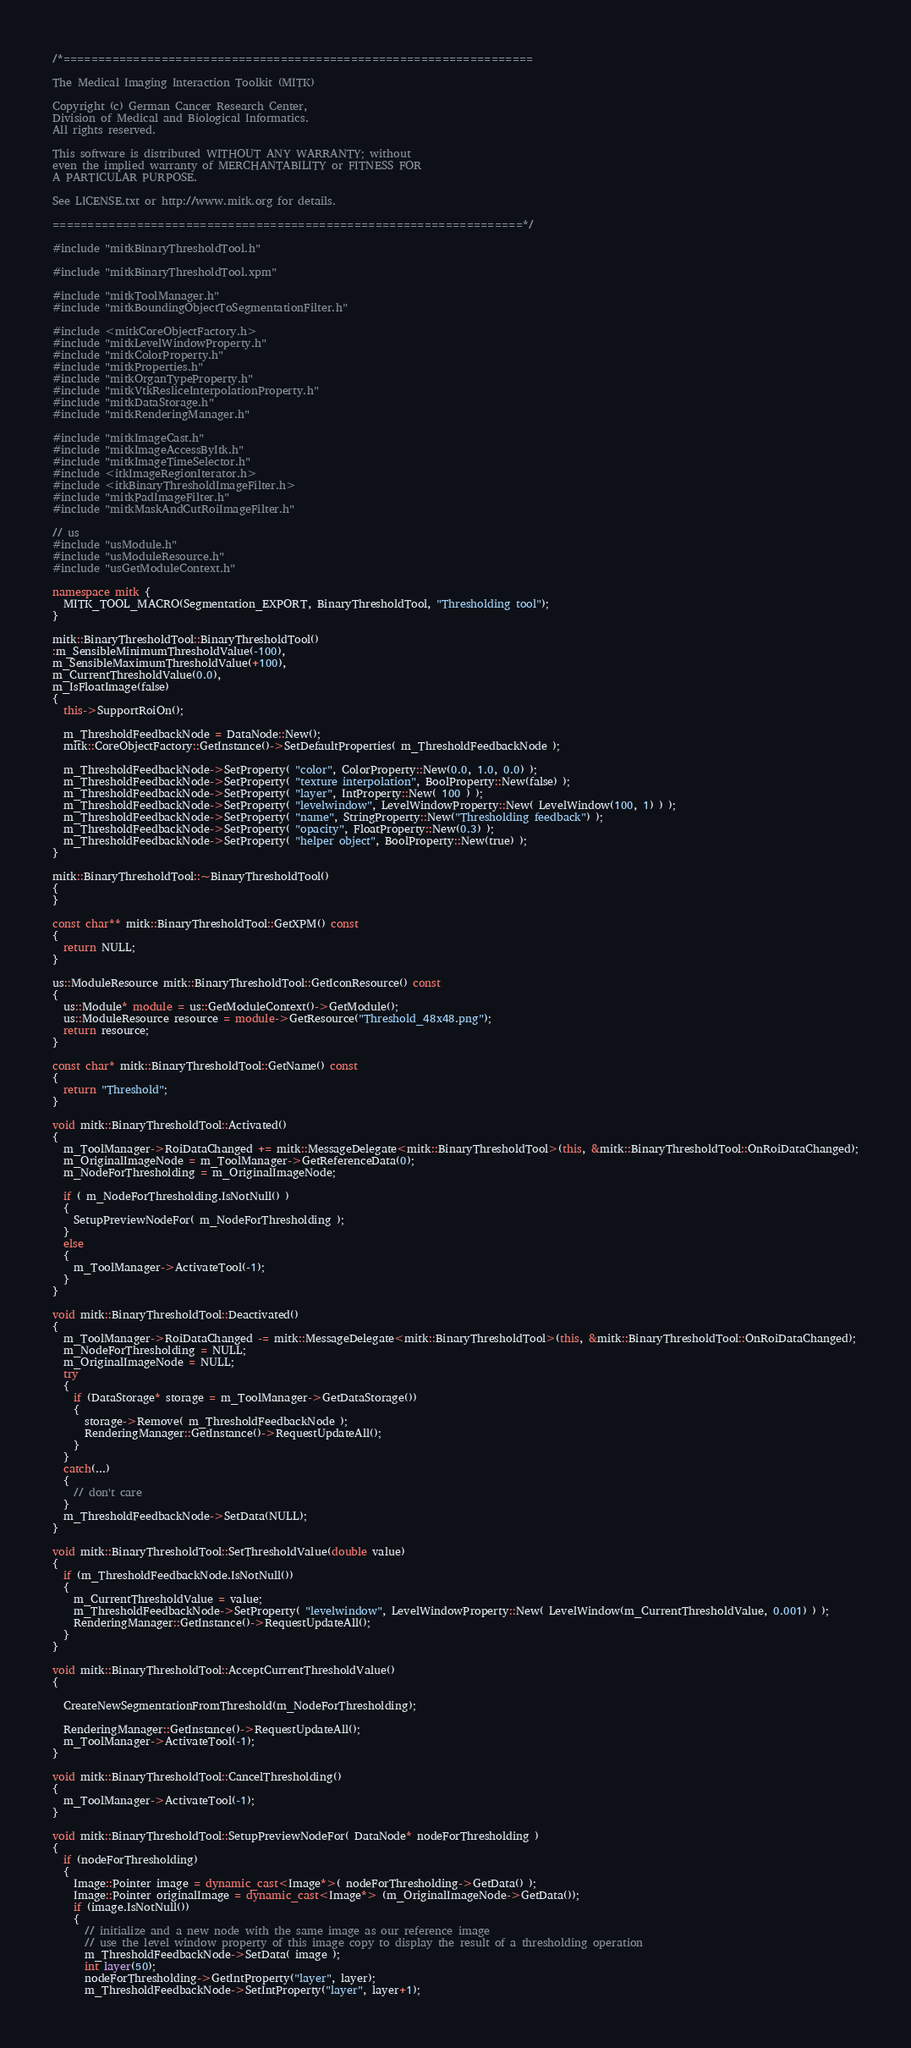Convert code to text. <code><loc_0><loc_0><loc_500><loc_500><_C++_>/*===================================================================

The Medical Imaging Interaction Toolkit (MITK)

Copyright (c) German Cancer Research Center,
Division of Medical and Biological Informatics.
All rights reserved.

This software is distributed WITHOUT ANY WARRANTY; without
even the implied warranty of MERCHANTABILITY or FITNESS FOR
A PARTICULAR PURPOSE.

See LICENSE.txt or http://www.mitk.org for details.

===================================================================*/

#include "mitkBinaryThresholdTool.h"

#include "mitkBinaryThresholdTool.xpm"

#include "mitkToolManager.h"
#include "mitkBoundingObjectToSegmentationFilter.h"

#include <mitkCoreObjectFactory.h>
#include "mitkLevelWindowProperty.h"
#include "mitkColorProperty.h"
#include "mitkProperties.h"
#include "mitkOrganTypeProperty.h"
#include "mitkVtkResliceInterpolationProperty.h"
#include "mitkDataStorage.h"
#include "mitkRenderingManager.h"

#include "mitkImageCast.h"
#include "mitkImageAccessByItk.h"
#include "mitkImageTimeSelector.h"
#include <itkImageRegionIterator.h>
#include <itkBinaryThresholdImageFilter.h>
#include "mitkPadImageFilter.h"
#include "mitkMaskAndCutRoiImageFilter.h"

// us
#include "usModule.h"
#include "usModuleResource.h"
#include "usGetModuleContext.h"

namespace mitk {
  MITK_TOOL_MACRO(Segmentation_EXPORT, BinaryThresholdTool, "Thresholding tool");
}

mitk::BinaryThresholdTool::BinaryThresholdTool()
:m_SensibleMinimumThresholdValue(-100),
m_SensibleMaximumThresholdValue(+100),
m_CurrentThresholdValue(0.0),
m_IsFloatImage(false)
{
  this->SupportRoiOn();

  m_ThresholdFeedbackNode = DataNode::New();
  mitk::CoreObjectFactory::GetInstance()->SetDefaultProperties( m_ThresholdFeedbackNode );

  m_ThresholdFeedbackNode->SetProperty( "color", ColorProperty::New(0.0, 1.0, 0.0) );
  m_ThresholdFeedbackNode->SetProperty( "texture interpolation", BoolProperty::New(false) );
  m_ThresholdFeedbackNode->SetProperty( "layer", IntProperty::New( 100 ) );
  m_ThresholdFeedbackNode->SetProperty( "levelwindow", LevelWindowProperty::New( LevelWindow(100, 1) ) );
  m_ThresholdFeedbackNode->SetProperty( "name", StringProperty::New("Thresholding feedback") );
  m_ThresholdFeedbackNode->SetProperty( "opacity", FloatProperty::New(0.3) );
  m_ThresholdFeedbackNode->SetProperty( "helper object", BoolProperty::New(true) );
}

mitk::BinaryThresholdTool::~BinaryThresholdTool()
{
}

const char** mitk::BinaryThresholdTool::GetXPM() const
{
  return NULL;
}

us::ModuleResource mitk::BinaryThresholdTool::GetIconResource() const
{
  us::Module* module = us::GetModuleContext()->GetModule();
  us::ModuleResource resource = module->GetResource("Threshold_48x48.png");
  return resource;
}

const char* mitk::BinaryThresholdTool::GetName() const
{
  return "Threshold";
}

void mitk::BinaryThresholdTool::Activated()
{
  m_ToolManager->RoiDataChanged += mitk::MessageDelegate<mitk::BinaryThresholdTool>(this, &mitk::BinaryThresholdTool::OnRoiDataChanged);
  m_OriginalImageNode = m_ToolManager->GetReferenceData(0);
  m_NodeForThresholding = m_OriginalImageNode;

  if ( m_NodeForThresholding.IsNotNull() )
  {
    SetupPreviewNodeFor( m_NodeForThresholding );
  }
  else
  {
    m_ToolManager->ActivateTool(-1);
  }
}

void mitk::BinaryThresholdTool::Deactivated()
{
  m_ToolManager->RoiDataChanged -= mitk::MessageDelegate<mitk::BinaryThresholdTool>(this, &mitk::BinaryThresholdTool::OnRoiDataChanged);
  m_NodeForThresholding = NULL;
  m_OriginalImageNode = NULL;
  try
  {
    if (DataStorage* storage = m_ToolManager->GetDataStorage())
    {
      storage->Remove( m_ThresholdFeedbackNode );
      RenderingManager::GetInstance()->RequestUpdateAll();
    }
  }
  catch(...)
  {
    // don't care
  }
  m_ThresholdFeedbackNode->SetData(NULL);
}

void mitk::BinaryThresholdTool::SetThresholdValue(double value)
{
  if (m_ThresholdFeedbackNode.IsNotNull())
  {
    m_CurrentThresholdValue = value;
    m_ThresholdFeedbackNode->SetProperty( "levelwindow", LevelWindowProperty::New( LevelWindow(m_CurrentThresholdValue, 0.001) ) );
    RenderingManager::GetInstance()->RequestUpdateAll();
  }
}

void mitk::BinaryThresholdTool::AcceptCurrentThresholdValue()
{

  CreateNewSegmentationFromThreshold(m_NodeForThresholding);

  RenderingManager::GetInstance()->RequestUpdateAll();
  m_ToolManager->ActivateTool(-1);
}

void mitk::BinaryThresholdTool::CancelThresholding()
{
  m_ToolManager->ActivateTool(-1);
}

void mitk::BinaryThresholdTool::SetupPreviewNodeFor( DataNode* nodeForThresholding )
{
  if (nodeForThresholding)
  {
    Image::Pointer image = dynamic_cast<Image*>( nodeForThresholding->GetData() );
    Image::Pointer originalImage = dynamic_cast<Image*> (m_OriginalImageNode->GetData());
    if (image.IsNotNull())
    {
      // initialize and a new node with the same image as our reference image
      // use the level window property of this image copy to display the result of a thresholding operation
      m_ThresholdFeedbackNode->SetData( image );
      int layer(50);
      nodeForThresholding->GetIntProperty("layer", layer);
      m_ThresholdFeedbackNode->SetIntProperty("layer", layer+1);
</code> 